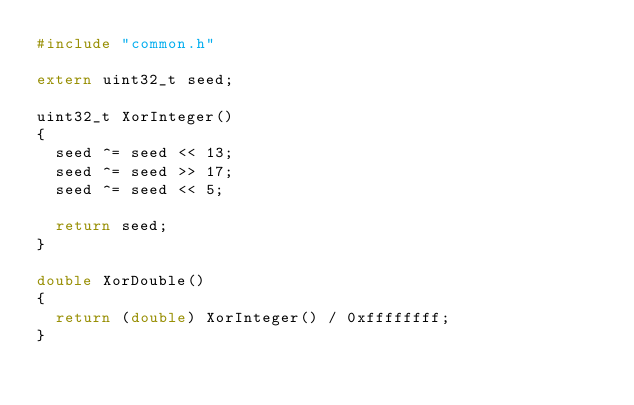<code> <loc_0><loc_0><loc_500><loc_500><_C_>#include "common.h"

extern uint32_t seed;

uint32_t XorInteger()
{
	seed ^= seed << 13;
	seed ^= seed >> 17;
	seed ^= seed << 5;

	return seed;
}

double XorDouble()
{
	return (double) XorInteger() / 0xffffffff;
}
</code> 